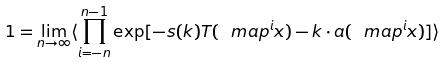<formula> <loc_0><loc_0><loc_500><loc_500>1 = \lim _ { n \rightarrow \infty } \langle \prod _ { i = - n } ^ { n - 1 } \exp [ - s ( { k } ) T ( \ m a p ^ { i } x ) - \i { k } \cdot { a } ( \ m a p ^ { i } x ) ] \rangle</formula> 